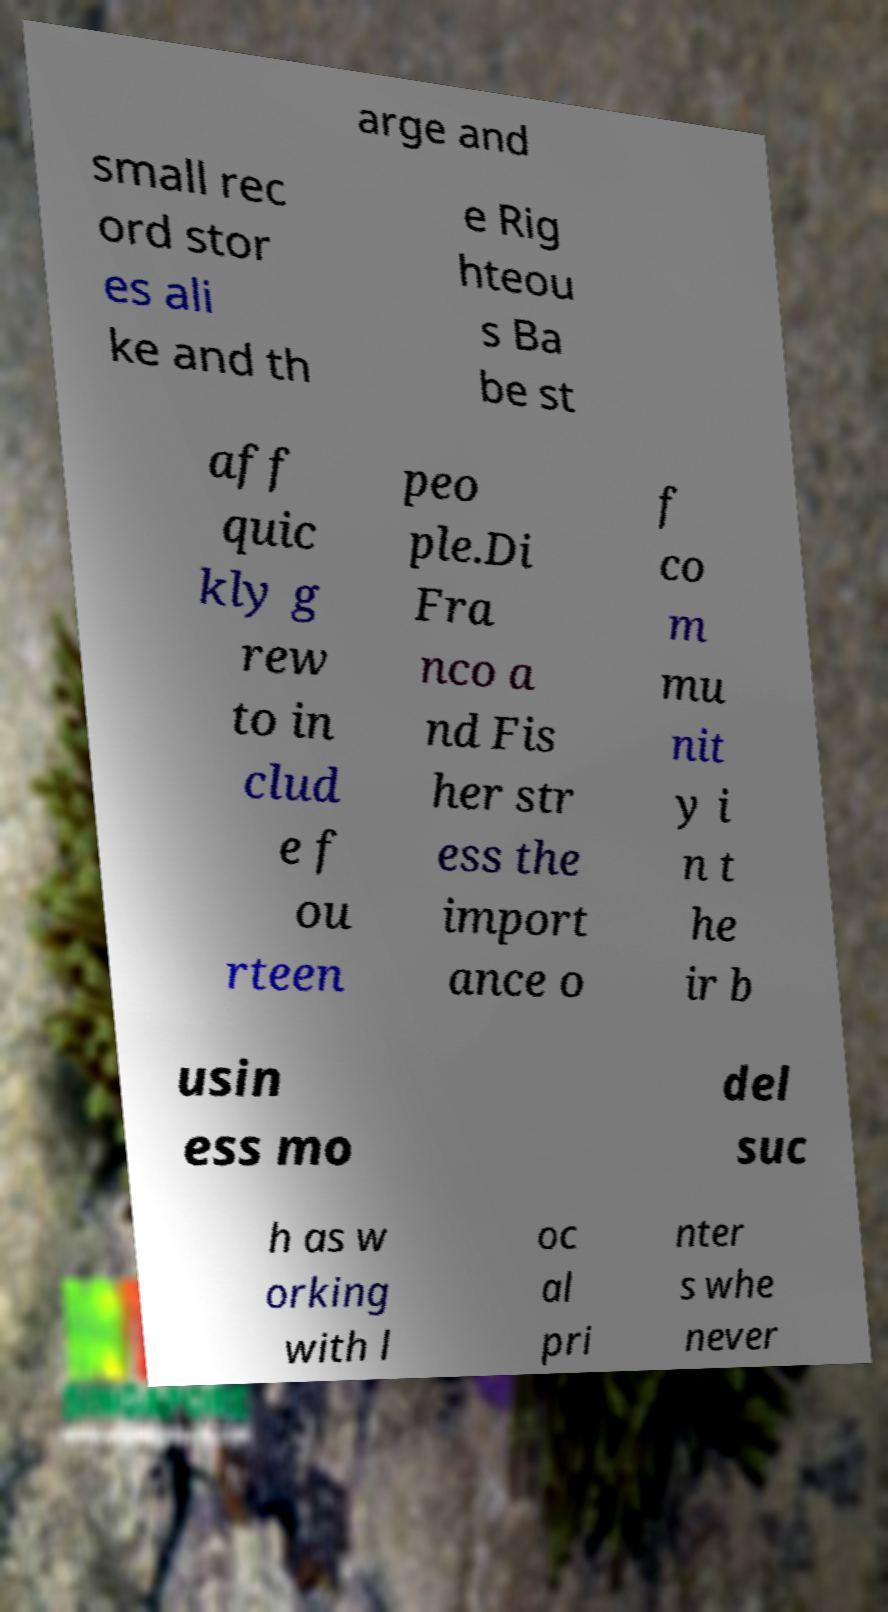Can you accurately transcribe the text from the provided image for me? arge and small rec ord stor es ali ke and th e Rig hteou s Ba be st aff quic kly g rew to in clud e f ou rteen peo ple.Di Fra nco a nd Fis her str ess the import ance o f co m mu nit y i n t he ir b usin ess mo del suc h as w orking with l oc al pri nter s whe never 